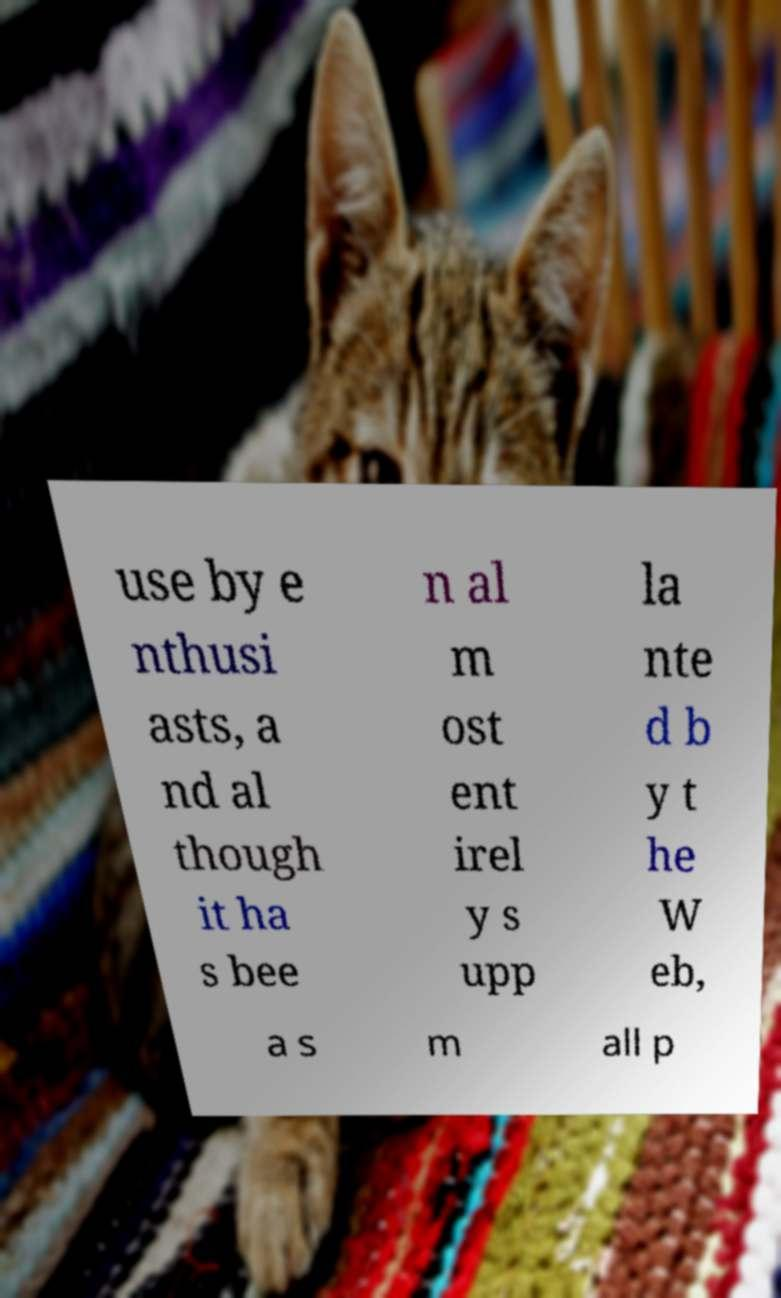I need the written content from this picture converted into text. Can you do that? use by e nthusi asts, a nd al though it ha s bee n al m ost ent irel y s upp la nte d b y t he W eb, a s m all p 